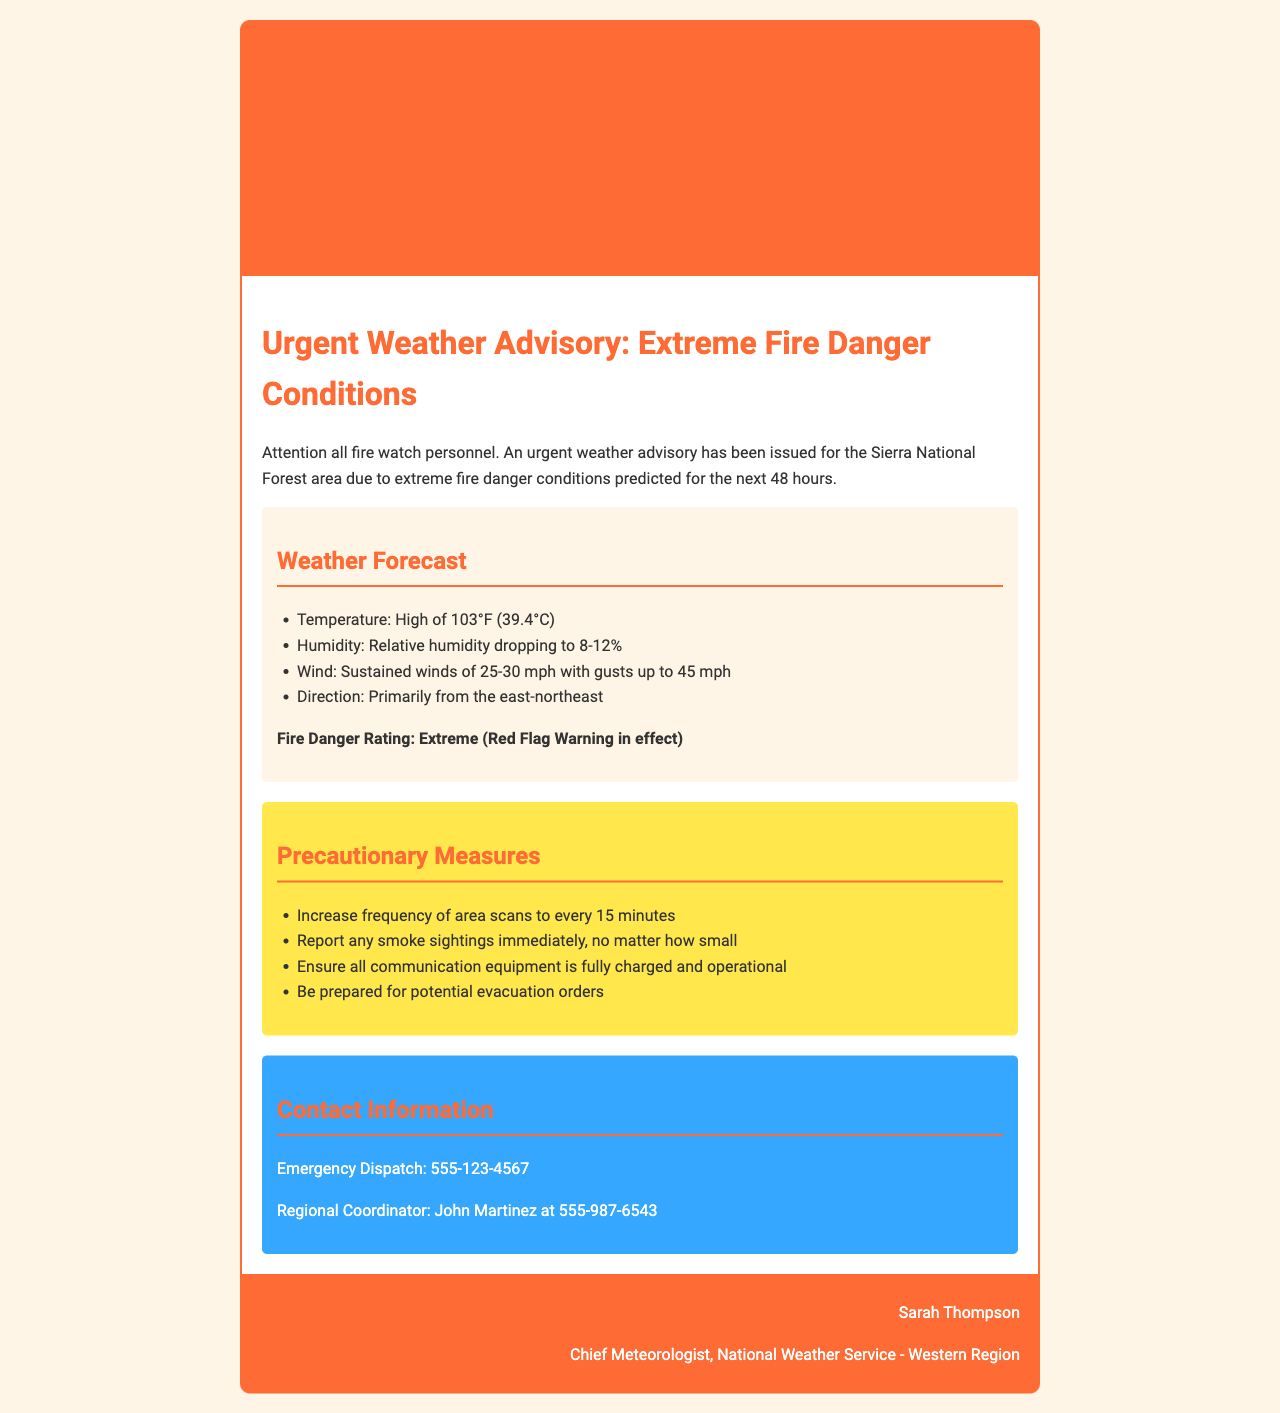What is the date of the advisory? The date of the advisory is clearly mentioned at the top of the document.
Answer: August 15, 2023 What is the predicted high temperature? The predicted high temperature is stated in the weather forecast section of the document.
Answer: 103°F (39.4°C) What is the relative humidity range? The relative humidity is provided as a specific range within the weather forecast section.
Answer: 8-12% What are the sustained winds? The document specifies the sustained winds in the weather forecast section.
Answer: 25-30 mph What precautions should be taken? The precautions are listed in a bullet format, indicating important measures to consider.
Answer: Increase frequency of area scans to every 15 minutes Who is the Chief Meteorologist? The footer of the document identifies the Chief Meteorologist's name and title.
Answer: Sarah Thompson What is the fire danger rating? The fire danger rating is stated in bold within the weather forecast section.
Answer: Extreme (Red Flag Warning in effect) What is the contact number for emergency dispatch? The contact information section provides specific phone numbers for emergencies.
Answer: 555-123-4567 From which direction are the winds primarily coming? The document specifies the wind direction in the weather forecast section.
Answer: East-northeast 